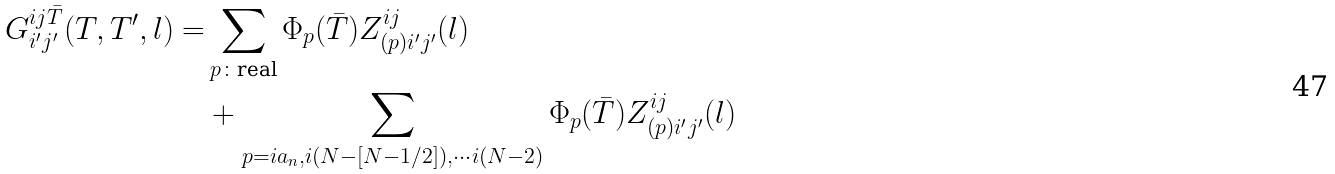Convert formula to latex. <formula><loc_0><loc_0><loc_500><loc_500>G ^ { i j \bar { T } } _ { i ^ { \prime } j ^ { \prime } } ( T , T ^ { \prime } , l ) = & \sum _ { p \colon \text {real} } \Phi _ { p } ( \bar { T } ) Z ^ { i j } _ { ( p ) i ^ { \prime } j ^ { \prime } } ( l ) \\ & + \sum _ { p = i a _ { n } , i ( N - [ N - 1 / 2 ] ) , \cdots i ( N - 2 ) } \Phi _ { p } ( \bar { T } ) Z ^ { i j } _ { ( p ) i ^ { \prime } j ^ { \prime } } ( l ) \\</formula> 